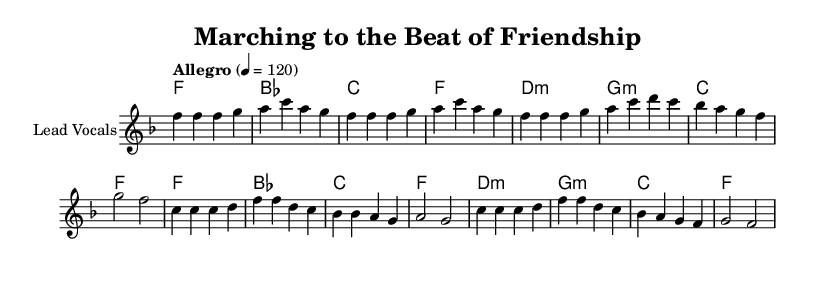What is the key signature of this music? The key signature is indicated at the beginning of the music. In this sheet, it shows one flat, which corresponds to the key of F major.
Answer: F major What is the time signature of this music? The time signature is displayed at the beginning of the music. Here, it is shown as 4/4, which means there are four beats in each measure.
Answer: 4/4 What is the tempo marking for this piece? The tempo marking is provided at the beginning of the music. It states "Allegro" with a metronome marking of 120, indicating a fast pace of play at 120 beats per minute.
Answer: Allegro 4 = 120 How many measures are in the verse section? To find this, we count the number of bar lines in the verse section. There are a total of 8 measures in the verse.
Answer: 8 What are the first two words of the chorus lyrics? The chorus lyrics start directly below the notes for the chorus section. The first two words are "Oh, the".
Answer: Oh, the Which chords are used in the chorus section? The chords are listed along with the corresponding lyrics in the chord mode section. The chorus uses the chords F, B flat, C, and F.
Answer: F, B flat, C, F What theme is highlighted in the lyrics of this song? By analyzing the lyrics, the song reflects on memories of friendship and youthful adventures, emphasizing camaraderie throughout the verses and chorus.
Answer: Friendship and youthful adventures 